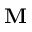Convert formula to latex. <formula><loc_0><loc_0><loc_500><loc_500>M</formula> 